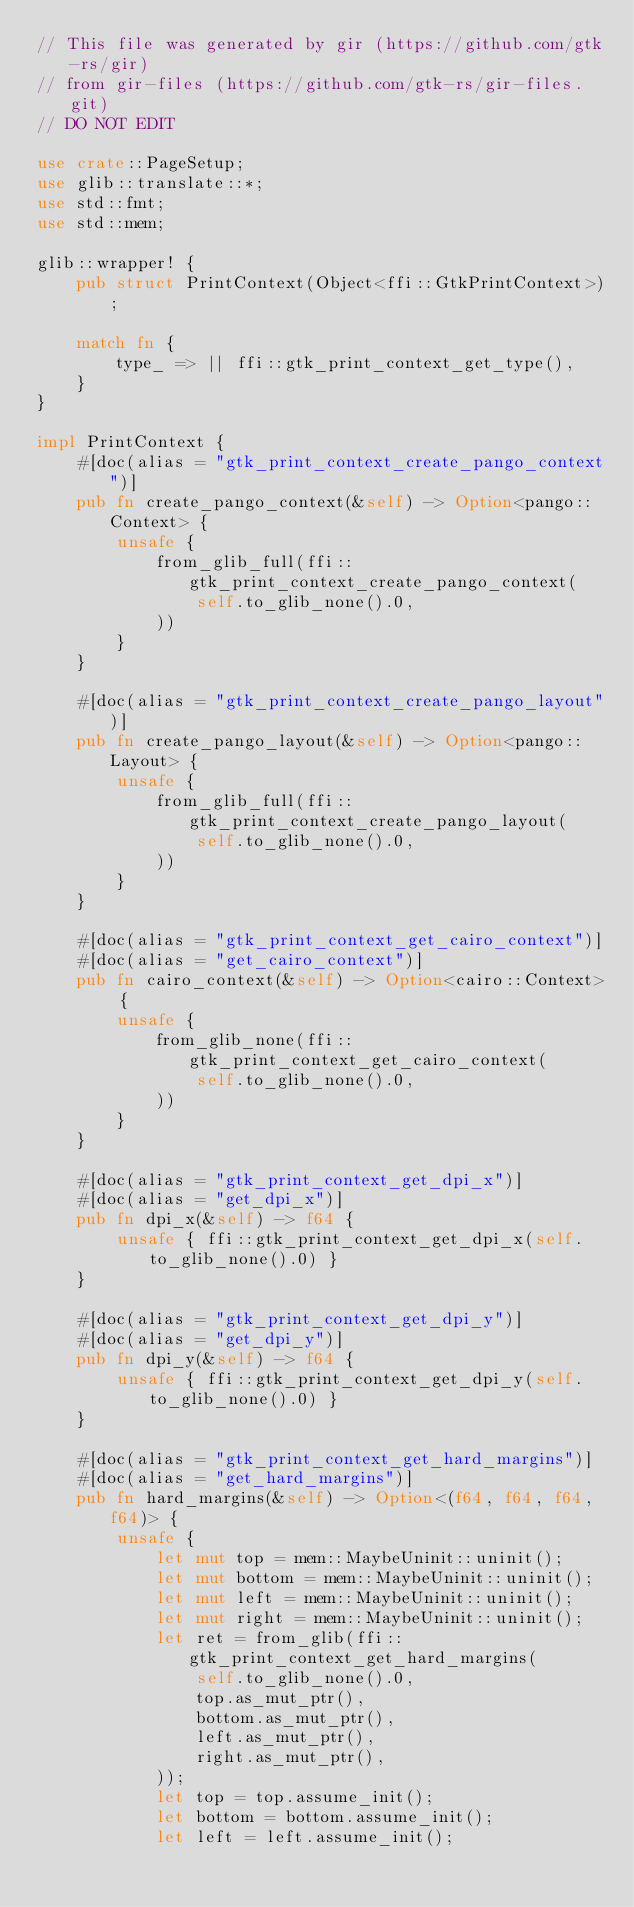Convert code to text. <code><loc_0><loc_0><loc_500><loc_500><_Rust_>// This file was generated by gir (https://github.com/gtk-rs/gir)
// from gir-files (https://github.com/gtk-rs/gir-files.git)
// DO NOT EDIT

use crate::PageSetup;
use glib::translate::*;
use std::fmt;
use std::mem;

glib::wrapper! {
    pub struct PrintContext(Object<ffi::GtkPrintContext>);

    match fn {
        type_ => || ffi::gtk_print_context_get_type(),
    }
}

impl PrintContext {
    #[doc(alias = "gtk_print_context_create_pango_context")]
    pub fn create_pango_context(&self) -> Option<pango::Context> {
        unsafe {
            from_glib_full(ffi::gtk_print_context_create_pango_context(
                self.to_glib_none().0,
            ))
        }
    }

    #[doc(alias = "gtk_print_context_create_pango_layout")]
    pub fn create_pango_layout(&self) -> Option<pango::Layout> {
        unsafe {
            from_glib_full(ffi::gtk_print_context_create_pango_layout(
                self.to_glib_none().0,
            ))
        }
    }

    #[doc(alias = "gtk_print_context_get_cairo_context")]
    #[doc(alias = "get_cairo_context")]
    pub fn cairo_context(&self) -> Option<cairo::Context> {
        unsafe {
            from_glib_none(ffi::gtk_print_context_get_cairo_context(
                self.to_glib_none().0,
            ))
        }
    }

    #[doc(alias = "gtk_print_context_get_dpi_x")]
    #[doc(alias = "get_dpi_x")]
    pub fn dpi_x(&self) -> f64 {
        unsafe { ffi::gtk_print_context_get_dpi_x(self.to_glib_none().0) }
    }

    #[doc(alias = "gtk_print_context_get_dpi_y")]
    #[doc(alias = "get_dpi_y")]
    pub fn dpi_y(&self) -> f64 {
        unsafe { ffi::gtk_print_context_get_dpi_y(self.to_glib_none().0) }
    }

    #[doc(alias = "gtk_print_context_get_hard_margins")]
    #[doc(alias = "get_hard_margins")]
    pub fn hard_margins(&self) -> Option<(f64, f64, f64, f64)> {
        unsafe {
            let mut top = mem::MaybeUninit::uninit();
            let mut bottom = mem::MaybeUninit::uninit();
            let mut left = mem::MaybeUninit::uninit();
            let mut right = mem::MaybeUninit::uninit();
            let ret = from_glib(ffi::gtk_print_context_get_hard_margins(
                self.to_glib_none().0,
                top.as_mut_ptr(),
                bottom.as_mut_ptr(),
                left.as_mut_ptr(),
                right.as_mut_ptr(),
            ));
            let top = top.assume_init();
            let bottom = bottom.assume_init();
            let left = left.assume_init();</code> 